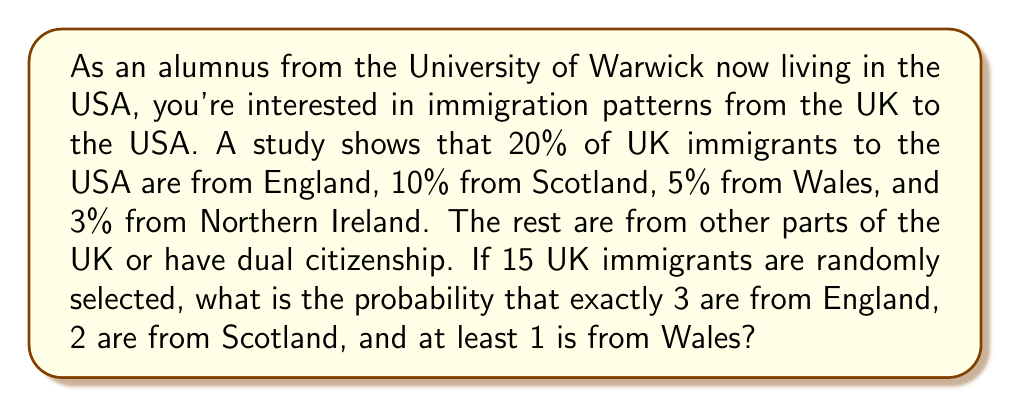Could you help me with this problem? Let's approach this step-by-step using the multinomial distribution and the complement rule.

1) First, let's define our events:
   $E$: exactly 3 from England
   $S$: exactly 2 from Scotland
   $W$: at least 1 from Wales

2) The probability for each category:
   $P(\text{England}) = 0.20$
   $P(\text{Scotland}) = 0.10$
   $P(\text{Wales}) = 0.05$
   $P(\text{Other}) = 1 - 0.20 - 0.10 - 0.05 = 0.65$

3) We can use the multinomial distribution for the exact numbers from England and Scotland:

   $$P(E \cap S) = \frac{15!}{3!2!(15-3-2)!} (0.20)^3 (0.10)^2 (0.70)^{10}$$

4) For Wales, we need at least 1, so it's easier to calculate the probability of 0 from Wales and subtract from 1:

   $$P(W) = 1 - (0.95)^{15}$$

5) Assuming independence, we can multiply these probabilities:

   $$P(E \cap S \cap W) = \frac{15!}{3!2!10!} (0.20)^3 (0.10)^2 (0.70)^{10} \cdot [1 - (0.95)^{15}]$$

6) Calculate:
   $$= 6435 \cdot 0.000008 \cdot 0.0001 \cdot 0.0282 \cdot 0.5367$$
   $$= 0.000000773 \text{ or approximately } 7.73 \times 10^{-7}$$
Answer: The probability is approximately $7.73 \times 10^{-7}$ or $0.000000773$. 